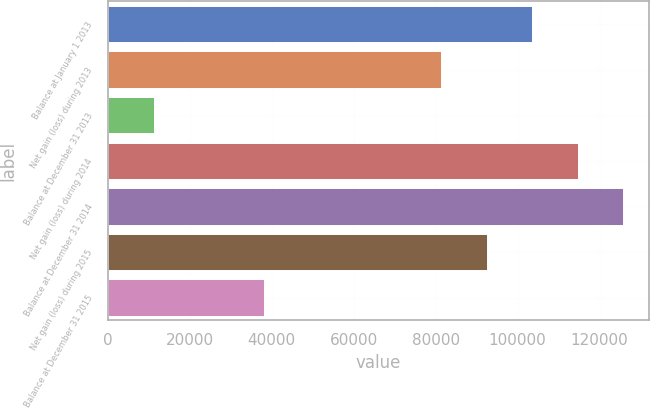Convert chart to OTSL. <chart><loc_0><loc_0><loc_500><loc_500><bar_chart><fcel>Balance at January 1 2013<fcel>Net gain (loss) during 2013<fcel>Balance at December 31 2013<fcel>Net gain (loss) during 2014<fcel>Balance at December 31 2014<fcel>Net gain (loss) during 2015<fcel>Balance at December 31 2015<nl><fcel>103565<fcel>81287<fcel>11294<fcel>114704<fcel>125843<fcel>92425.9<fcel>38166<nl></chart> 